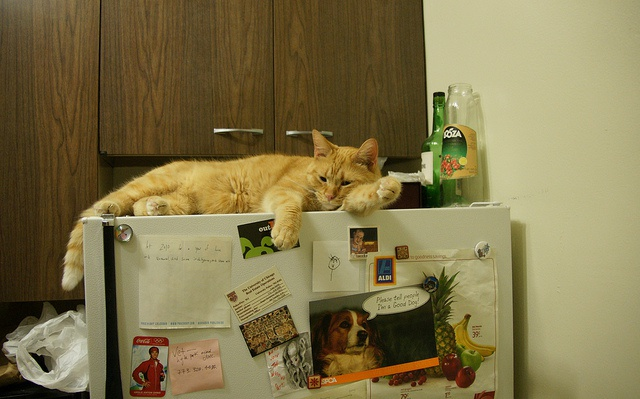Describe the objects in this image and their specific colors. I can see refrigerator in olive, tan, and black tones, cat in olive and tan tones, bottle in olive, tan, and darkgreen tones, dog in olive, black, and maroon tones, and bottle in olive, black, green, darkgreen, and beige tones in this image. 